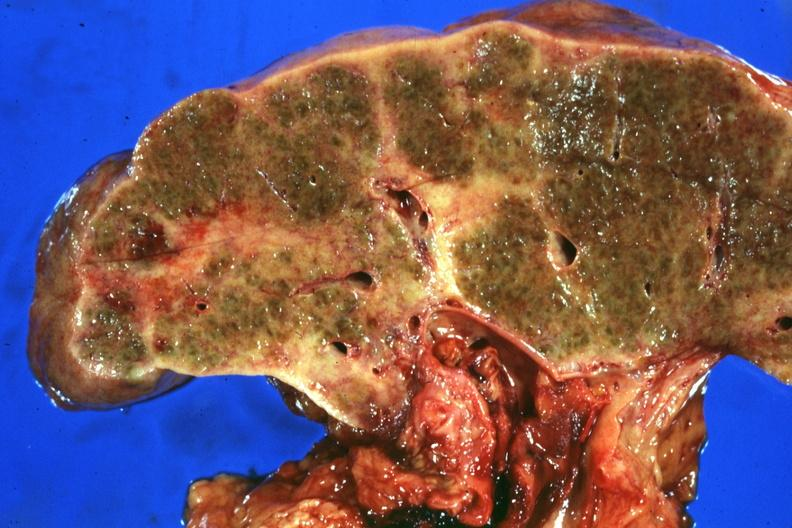what is present?
Answer the question using a single word or phrase. Hepatobiliary 